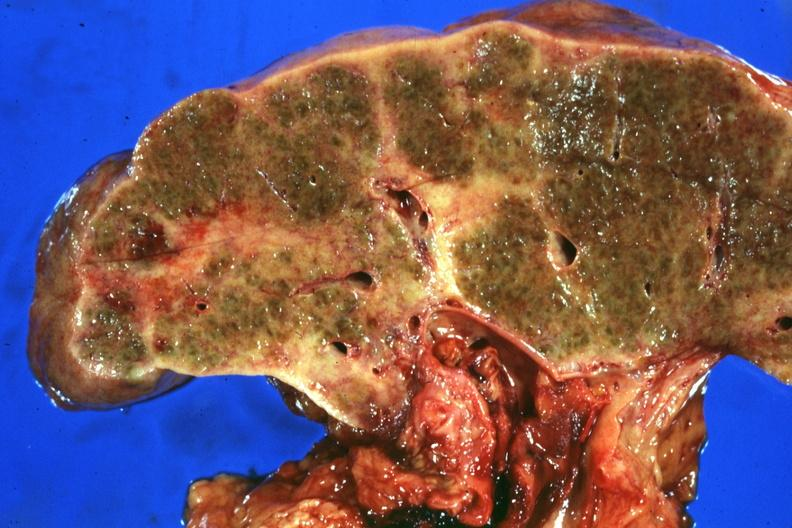what is present?
Answer the question using a single word or phrase. Hepatobiliary 